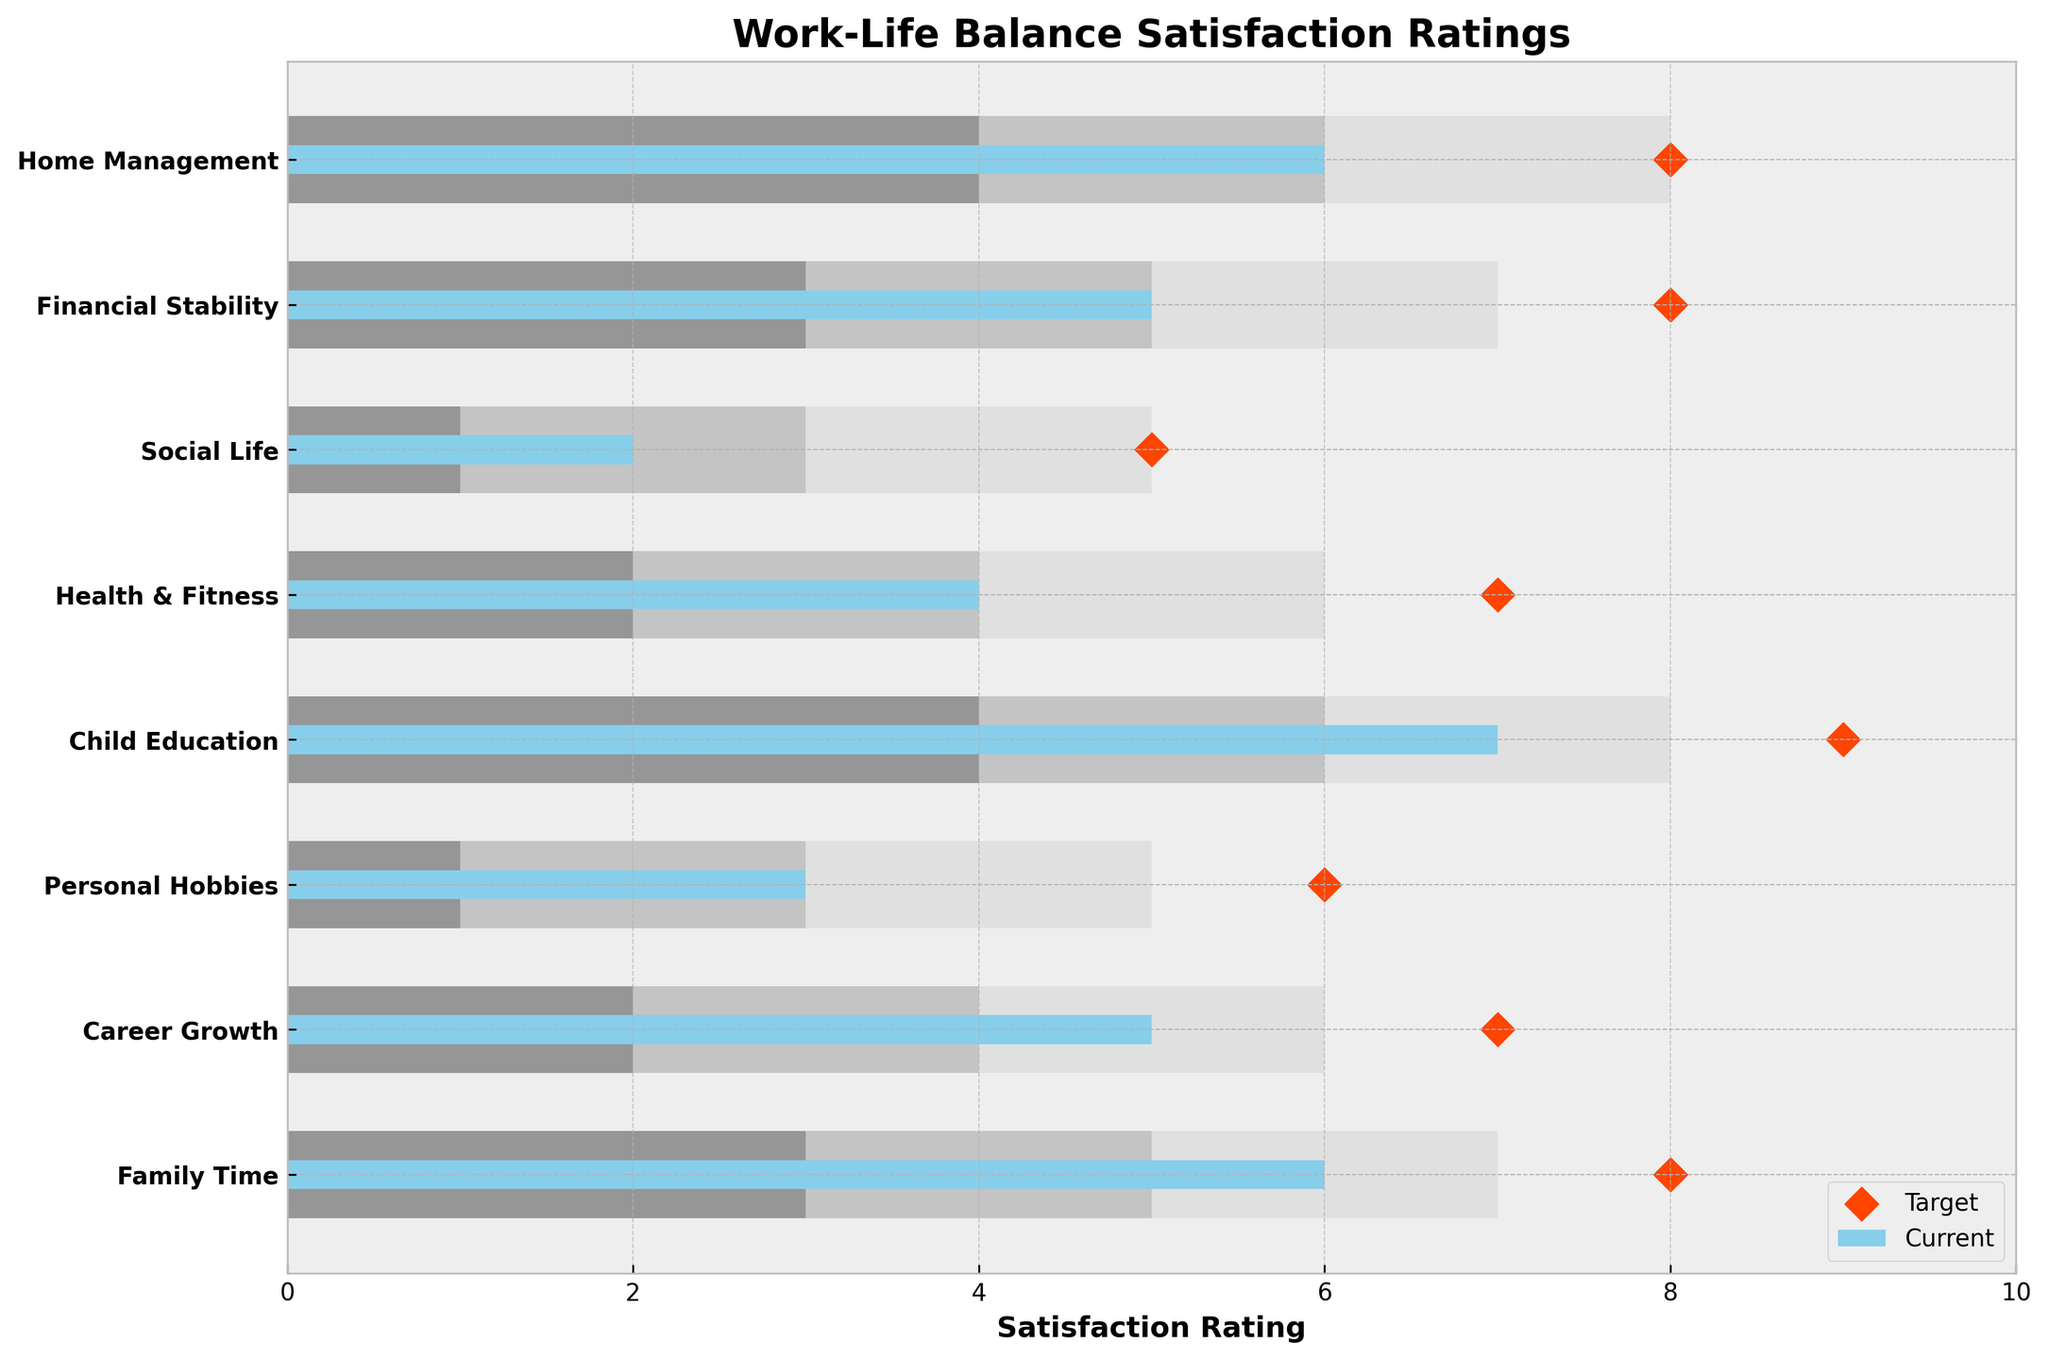What aspect has the highest current satisfaction rating? Look at the bar representing the 'Current' satisfaction values and find the tallest bar among all aspects.
Answer: Child Education What is the target satisfaction rating for Family Time? Look for the diamond marker representing the target value aligned with the Family Time row.
Answer: 8 How far is the current satisfaction rating from the target for Personal Hobbies? Compare the current value bar for Personal Hobbies with the corresponding target value which is the diamond marker. Subtract the current value from the target (6 - 3).
Answer: 3 Which aspect has a satisfaction rating in the 'High' range starting from 7? Check the light grey bars and find the aspects where the high range (7-10) is covered.
Answer: Family Time, Child Education, Financial Stability, Home Management What is the combined total of the 'Medium' satisfaction ranges? Sum the lengths of the medium grey bars for all aspects. Calculate as follows: (5+4+3+6+4+3+5+6).
Answer: 36 Which aspect has the lowest current satisfaction rating? Identify the smallest bar in the 'Current' satisfaction values.
Answer: Social Life For Health & Fitness, what is the midpoint of the 'Low' satisfaction range? The 'Low' range for Health & Fitness spans from 0 to 2, so the midpoint is (2/2).
Answer: 1 If the target satisfaction for Social Life is achieved, how much difference will it make from the current rating? Calculate the difference by subtracting the current value of Social Life from its target (5 - 2).
Answer: 3 Is any aspect meeting its 'High' satisfaction target? Look where the target value, represented by the diamond marker, lies within the 'High' satisfaction grey bar zone.
Answer: No Which two aspects have the same current satisfaction rating? Compare the 'Current' satisfaction bars to identify equal values.
Answer: Career Growth, Financial Stability 